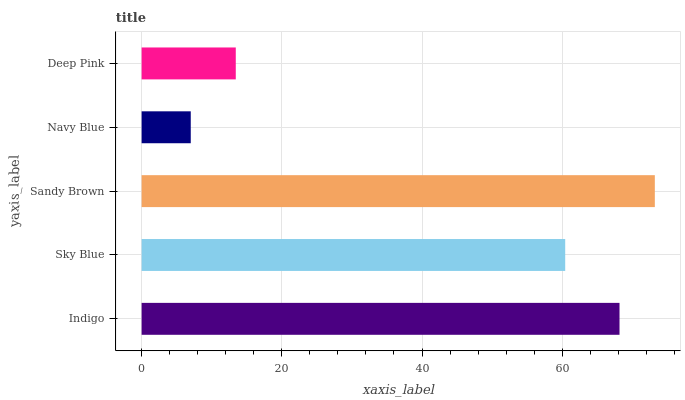Is Navy Blue the minimum?
Answer yes or no. Yes. Is Sandy Brown the maximum?
Answer yes or no. Yes. Is Sky Blue the minimum?
Answer yes or no. No. Is Sky Blue the maximum?
Answer yes or no. No. Is Indigo greater than Sky Blue?
Answer yes or no. Yes. Is Sky Blue less than Indigo?
Answer yes or no. Yes. Is Sky Blue greater than Indigo?
Answer yes or no. No. Is Indigo less than Sky Blue?
Answer yes or no. No. Is Sky Blue the high median?
Answer yes or no. Yes. Is Sky Blue the low median?
Answer yes or no. Yes. Is Deep Pink the high median?
Answer yes or no. No. Is Indigo the low median?
Answer yes or no. No. 